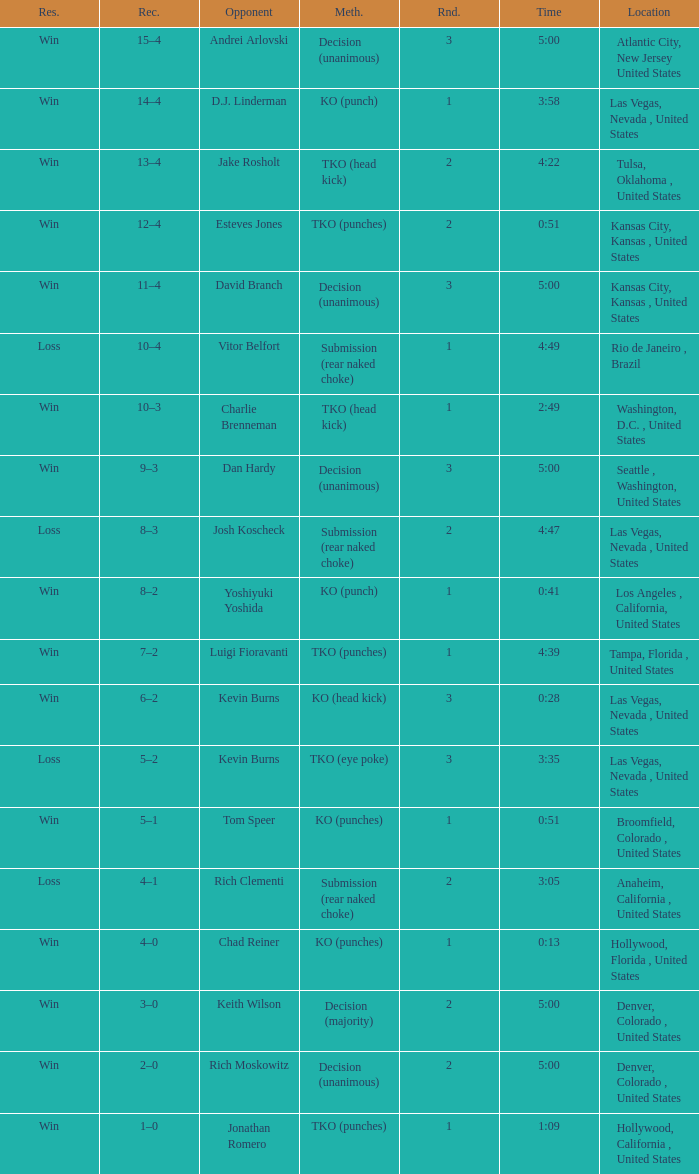Which record has a time of 0:13? 4–0. 